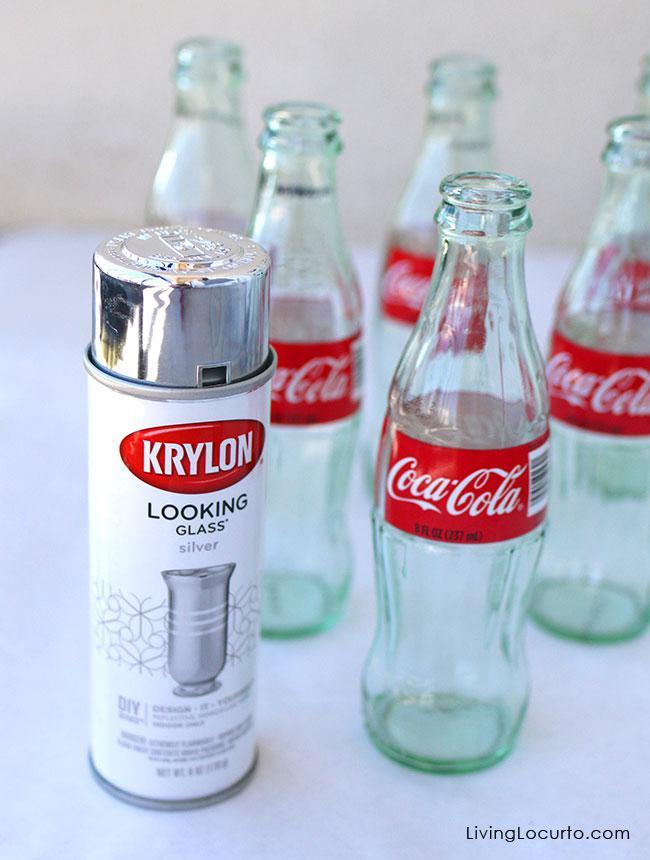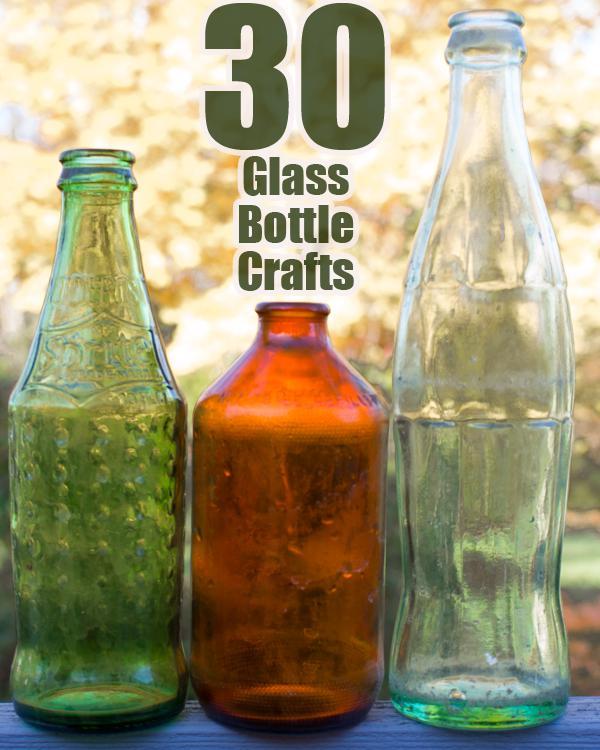The first image is the image on the left, the second image is the image on the right. Evaluate the accuracy of this statement regarding the images: "There are exactly two bottles.". Is it true? Answer yes or no. No. The first image is the image on the left, the second image is the image on the right. Examine the images to the left and right. Is the description "One image contains several evenly spaced glass soda bottles with white lettering on red labels." accurate? Answer yes or no. Yes. 